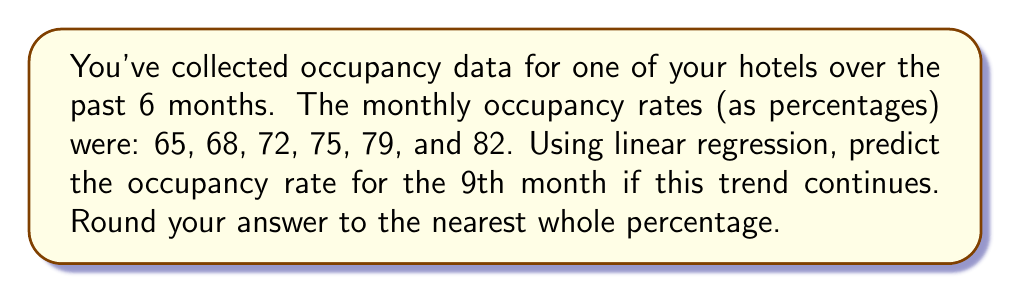Can you answer this question? Let's solve this step-by-step using linear regression:

1) First, let's set up our data points:
   x (month): 1, 2, 3, 4, 5, 6
   y (occupancy rate): 65, 68, 72, 75, 79, 82

2) We need to calculate the following:
   $n = 6$ (number of data points)
   $\sum x = 1 + 2 + 3 + 4 + 5 + 6 = 21$
   $\sum y = 65 + 68 + 72 + 75 + 79 + 82 = 441$
   $\sum xy = (1)(65) + (2)(68) + (3)(72) + (4)(75) + (5)(79) + (6)(82) = 1749$
   $\sum x^2 = 1^2 + 2^2 + 3^2 + 4^2 + 5^2 + 6^2 = 91$

3) The linear regression equation is $y = mx + b$, where:

   $m = \frac{n\sum xy - \sum x \sum y}{n\sum x^2 - (\sum x)^2}$
   
   $b = \frac{\sum y - m\sum x}{n}$

4) Let's calculate $m$:
   $$m = \frac{6(1749) - 21(441)}{6(91) - 21^2} = \frac{10494 - 9261}{546 - 441} = \frac{1233}{105} = 3.4$$

5) Now let's calculate $b$:
   $$b = \frac{441 - 3.4(21)}{6} = \frac{441 - 71.4}{6} = 61.6$$

6) Our linear regression equation is therefore:
   $y = 3.4x + 61.6$

7) To predict the occupancy rate for the 9th month, we substitute $x = 9$:
   $y = 3.4(9) + 61.6 = 30.6 + 61.6 = 92.2$

8) Rounding to the nearest whole percentage:
   92.2% ≈ 92%
Answer: 92% 